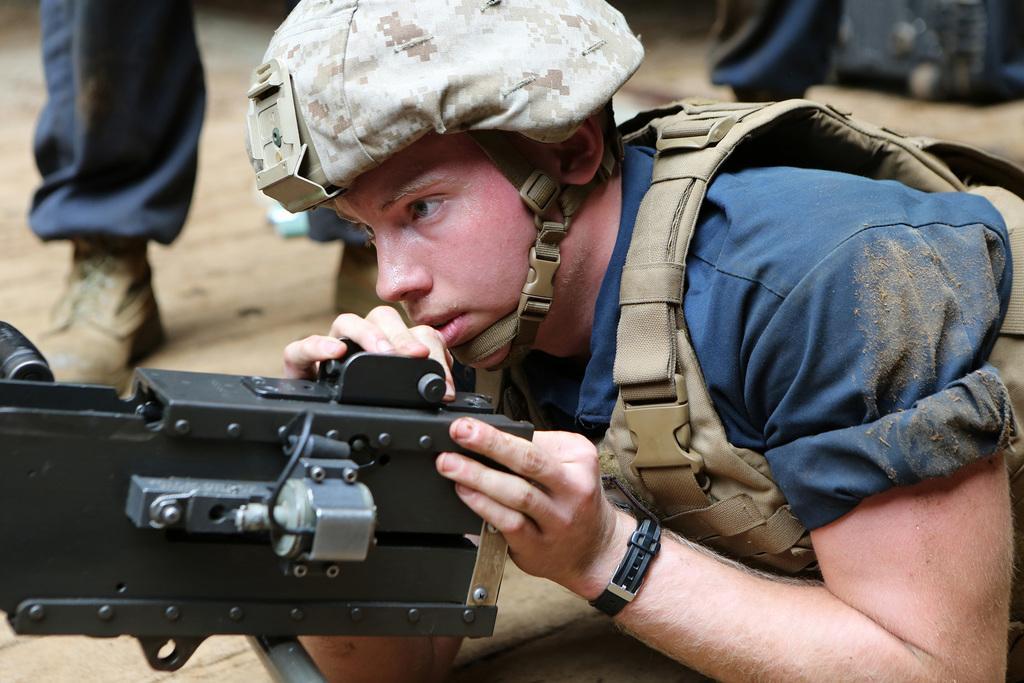Could you give a brief overview of what you see in this image? In this image we can see a person lying on the ground and holding the machine gun. In the background we can see persons standing. 